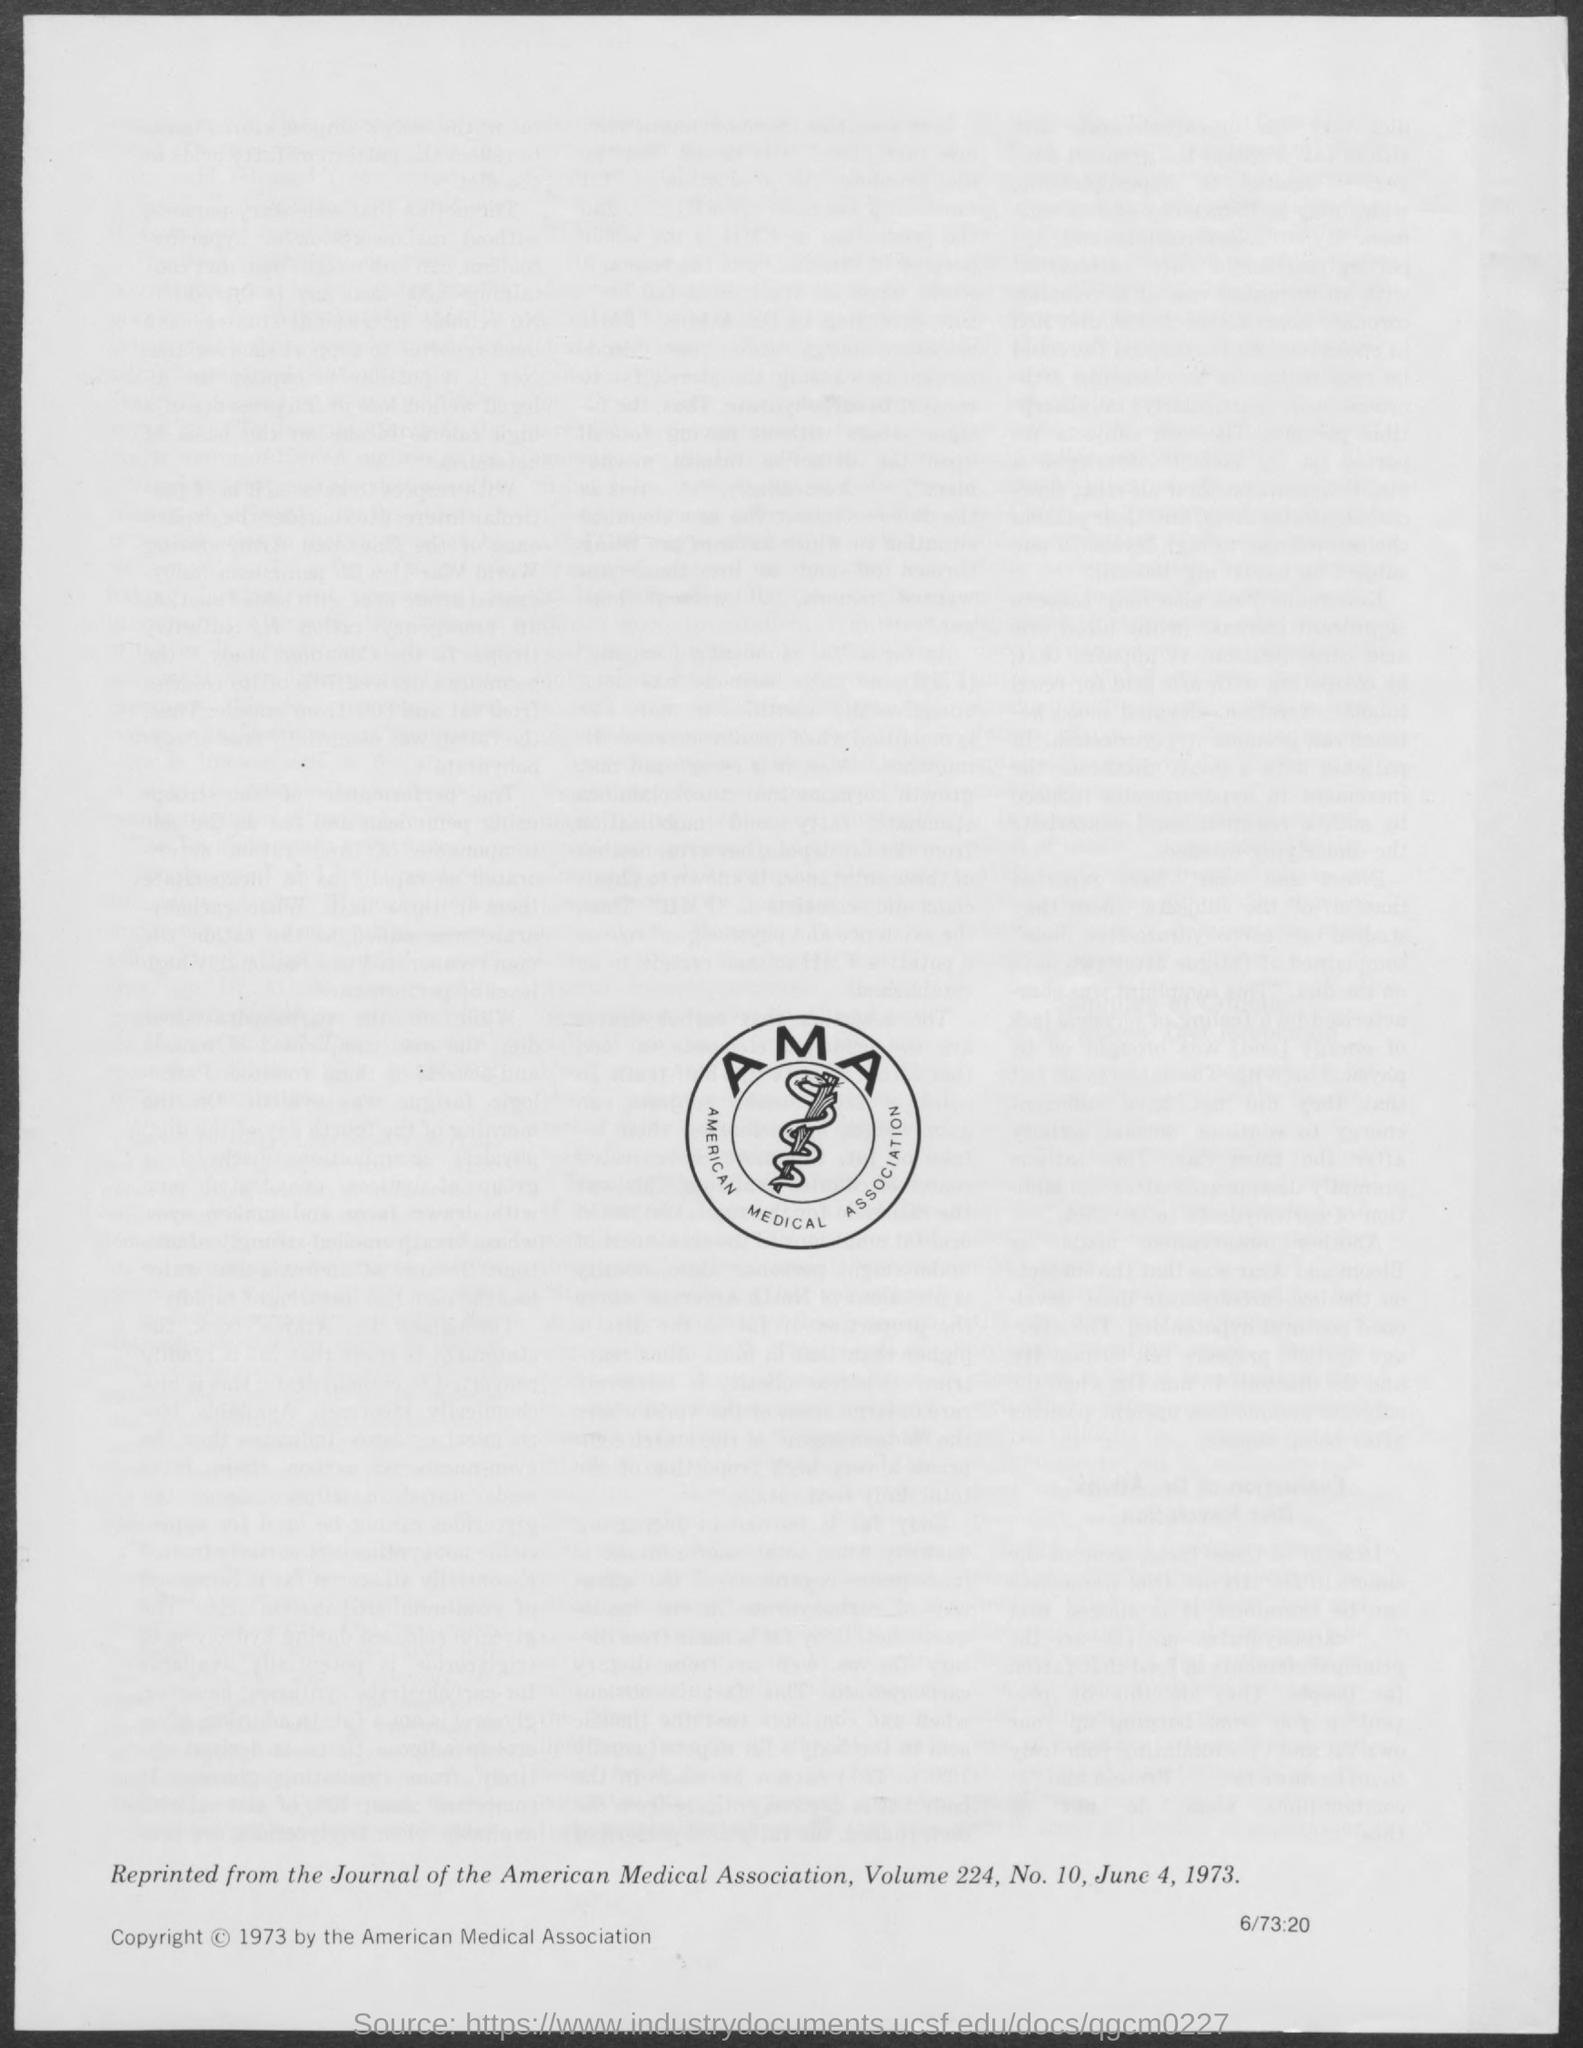Point out several critical features in this image. The date mentioned in the document is June 4, 1973. The American Medical Association (AMA) is a professional organization of physicians in the United States. 